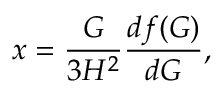Convert formula to latex. <formula><loc_0><loc_0><loc_500><loc_500>x = \frac { G } { 3 H ^ { 2 } } \frac { d f ( G ) } { d G } ,</formula> 